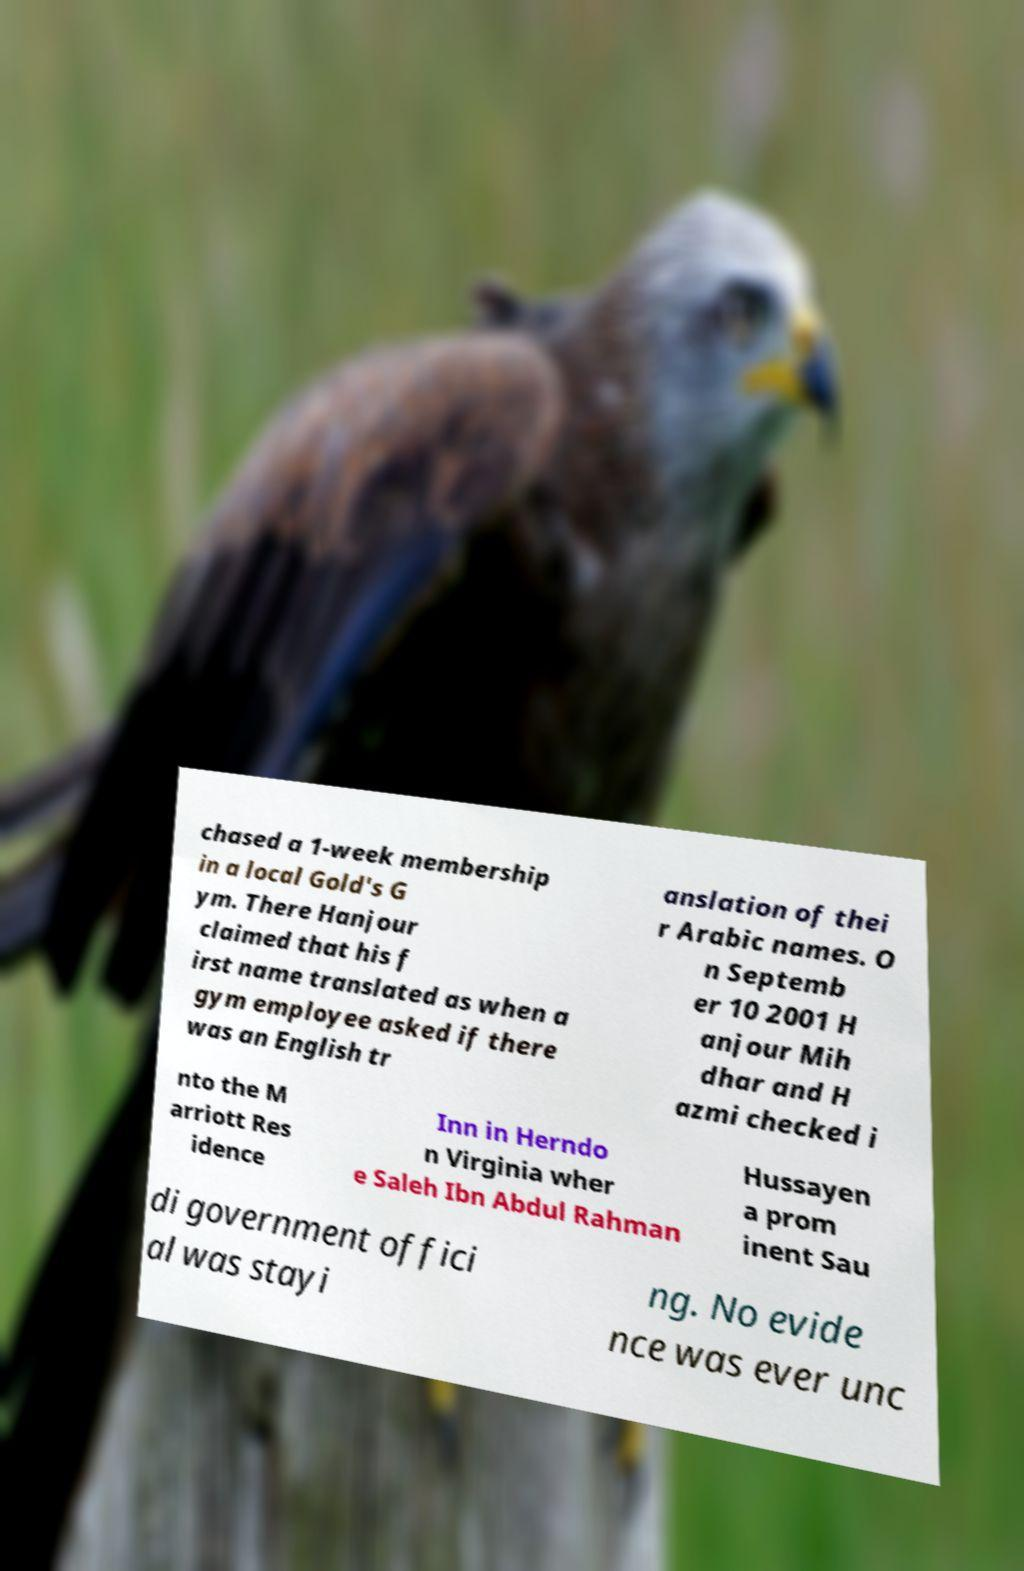For documentation purposes, I need the text within this image transcribed. Could you provide that? chased a 1-week membership in a local Gold's G ym. There Hanjour claimed that his f irst name translated as when a gym employee asked if there was an English tr anslation of thei r Arabic names. O n Septemb er 10 2001 H anjour Mih dhar and H azmi checked i nto the M arriott Res idence Inn in Herndo n Virginia wher e Saleh Ibn Abdul Rahman Hussayen a prom inent Sau di government offici al was stayi ng. No evide nce was ever unc 